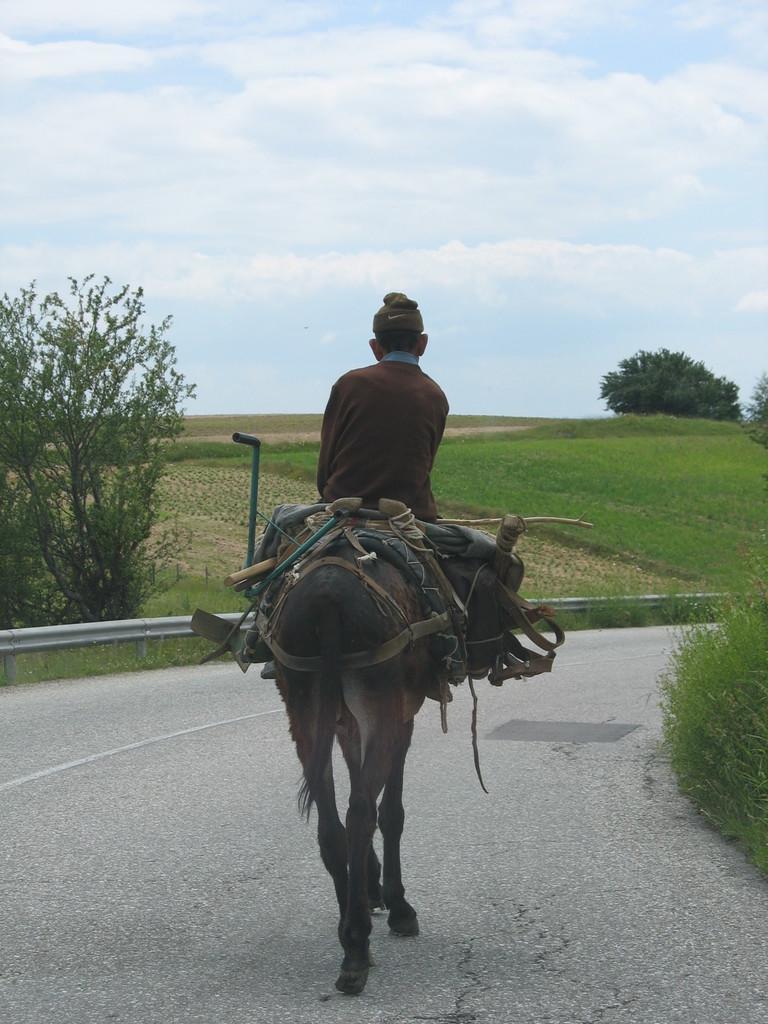Could you give a brief overview of what you see in this image? In this image I see a men who is sitting on an animal and it is on the path. In the background I see few trees, grass and the sky. 